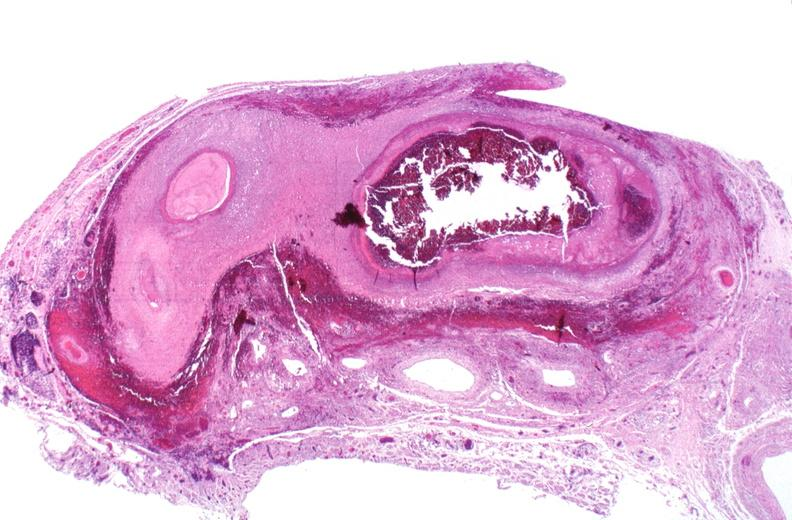what is present?
Answer the question using a single word or phrase. Vasculature 